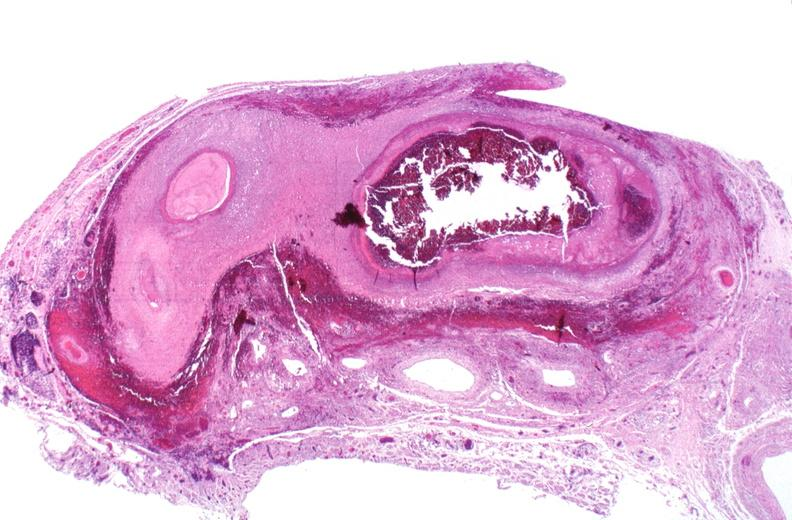what is present?
Answer the question using a single word or phrase. Vasculature 